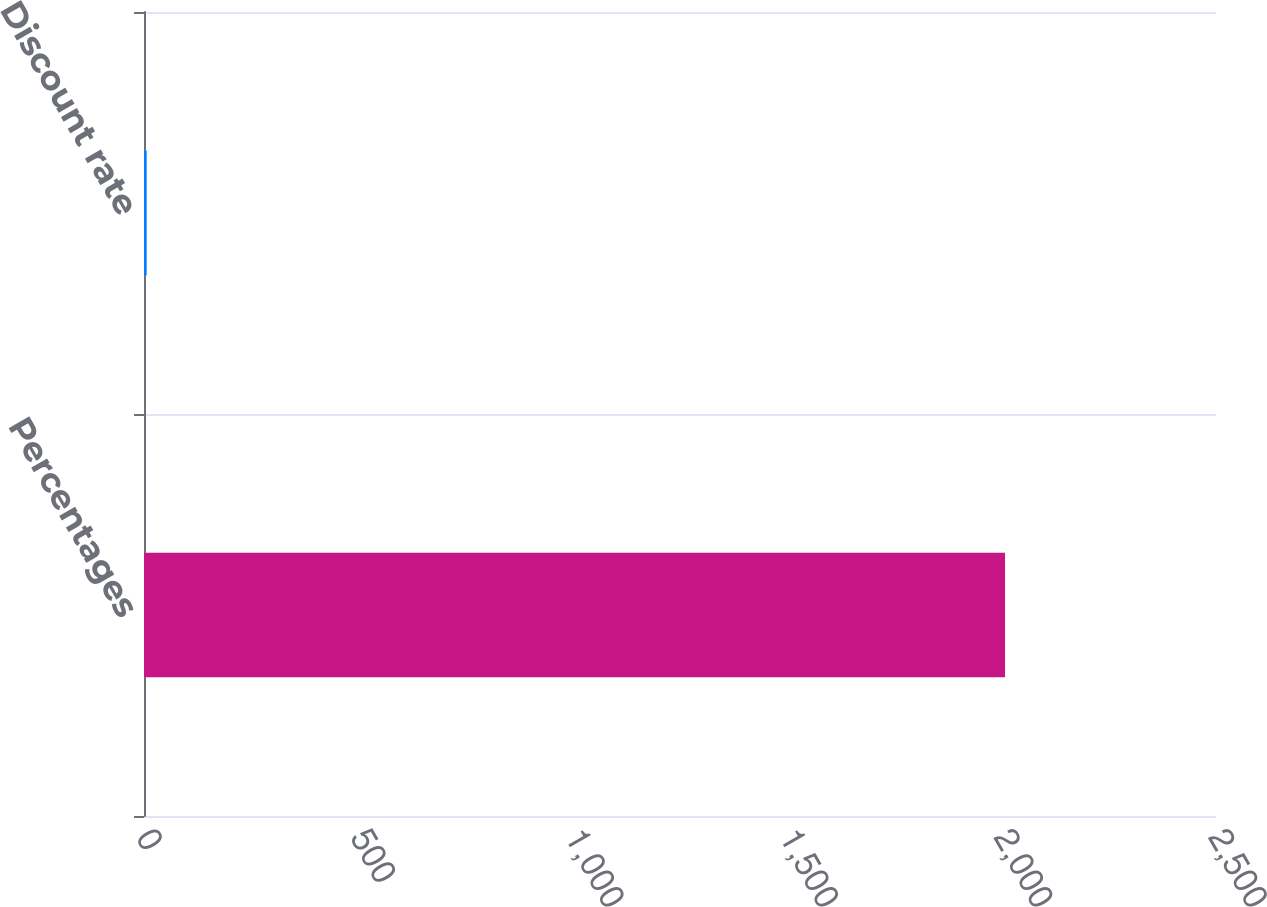Convert chart. <chart><loc_0><loc_0><loc_500><loc_500><bar_chart><fcel>Percentages<fcel>Discount rate<nl><fcel>2008<fcel>6.25<nl></chart> 